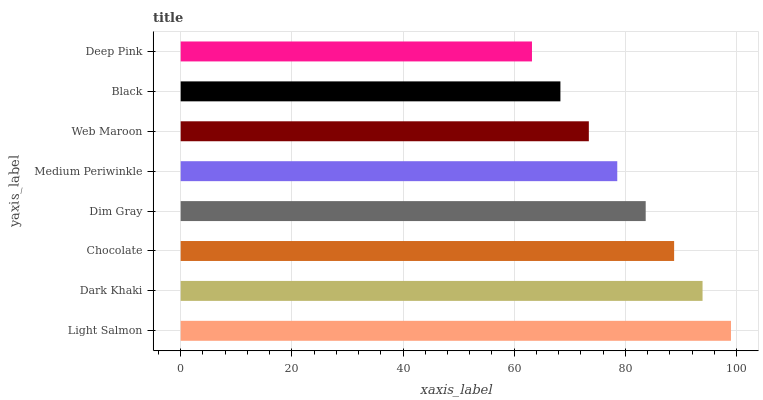Is Deep Pink the minimum?
Answer yes or no. Yes. Is Light Salmon the maximum?
Answer yes or no. Yes. Is Dark Khaki the minimum?
Answer yes or no. No. Is Dark Khaki the maximum?
Answer yes or no. No. Is Light Salmon greater than Dark Khaki?
Answer yes or no. Yes. Is Dark Khaki less than Light Salmon?
Answer yes or no. Yes. Is Dark Khaki greater than Light Salmon?
Answer yes or no. No. Is Light Salmon less than Dark Khaki?
Answer yes or no. No. Is Dim Gray the high median?
Answer yes or no. Yes. Is Medium Periwinkle the low median?
Answer yes or no. Yes. Is Dark Khaki the high median?
Answer yes or no. No. Is Light Salmon the low median?
Answer yes or no. No. 